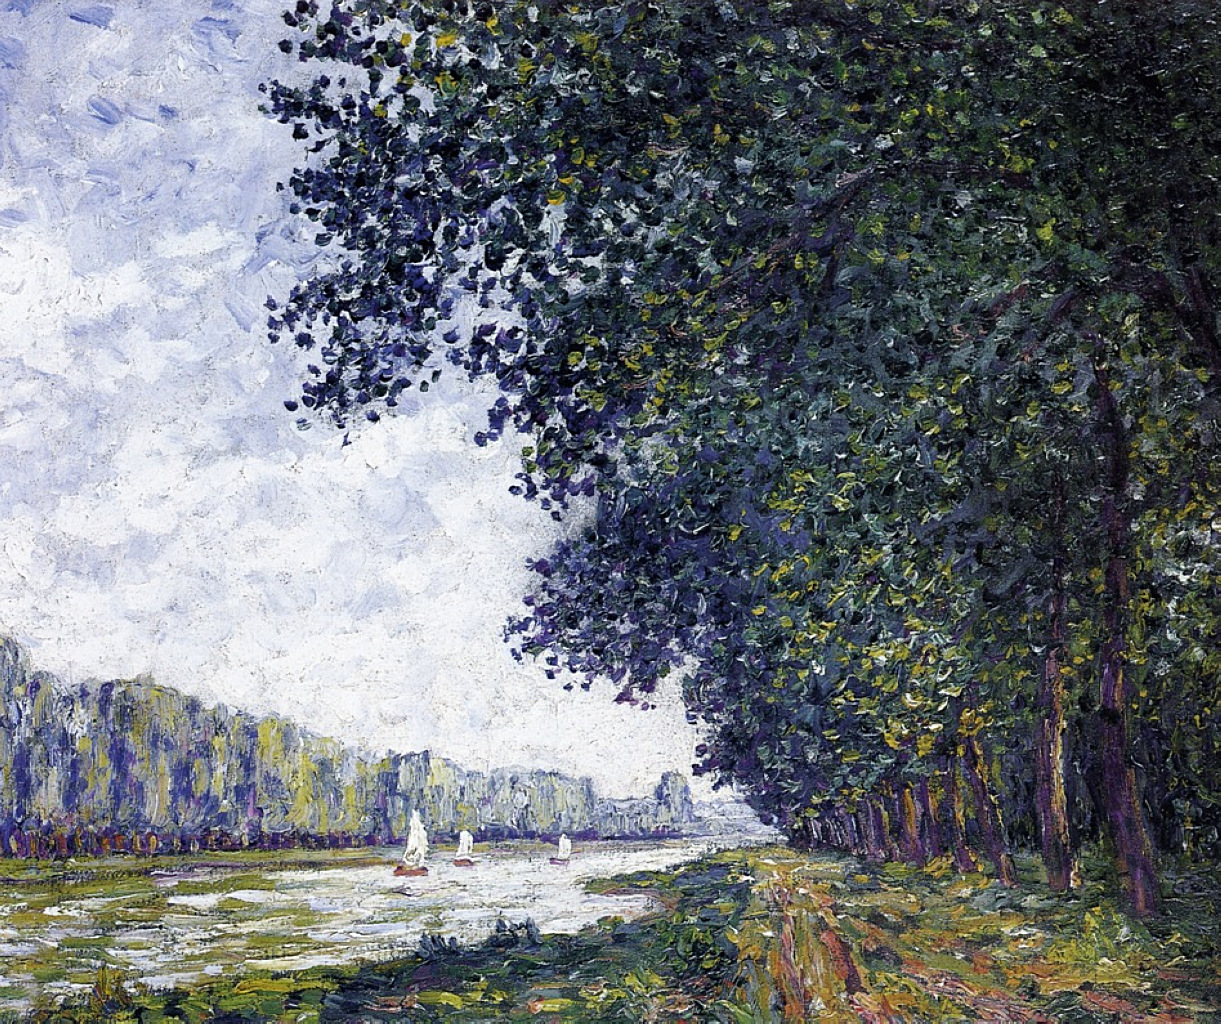Can you elaborate on the elements of the picture provided? The image portrays a stunning impressionist painting depicting a tranquil river scene. The calmness of the river is only occasionally interrupted by the gentle movement of several sailboats, which appear to float effortlessly upon the water painted in soothing shades of blue. On the left side of the river, a pathway is invitingly depicted, drawing viewers into the peaceful landscape.

The right side showcases tall, majestic trees adorned with rich green foliage that stands in stark contrast to the blue waters of the river. The artist employs a distinctive painterly style, with visible brushstrokes that bring a lively sense of movement and energy to the scene. 

Warm tones of yellow and red subtly infuse the composition, adding a sense of warmth and vitality, while the distant city skyline introduces depth and perspective to the painting. The predominant color palette of blue, green, and white promotes a serene and calming atmosphere. 

As a classic example of impressionist art, the painting focuses on the transient effects of light and color through loose brushwork. This technique effectively captures a fleeting moment in nature, filled with authenticity and emotion. 